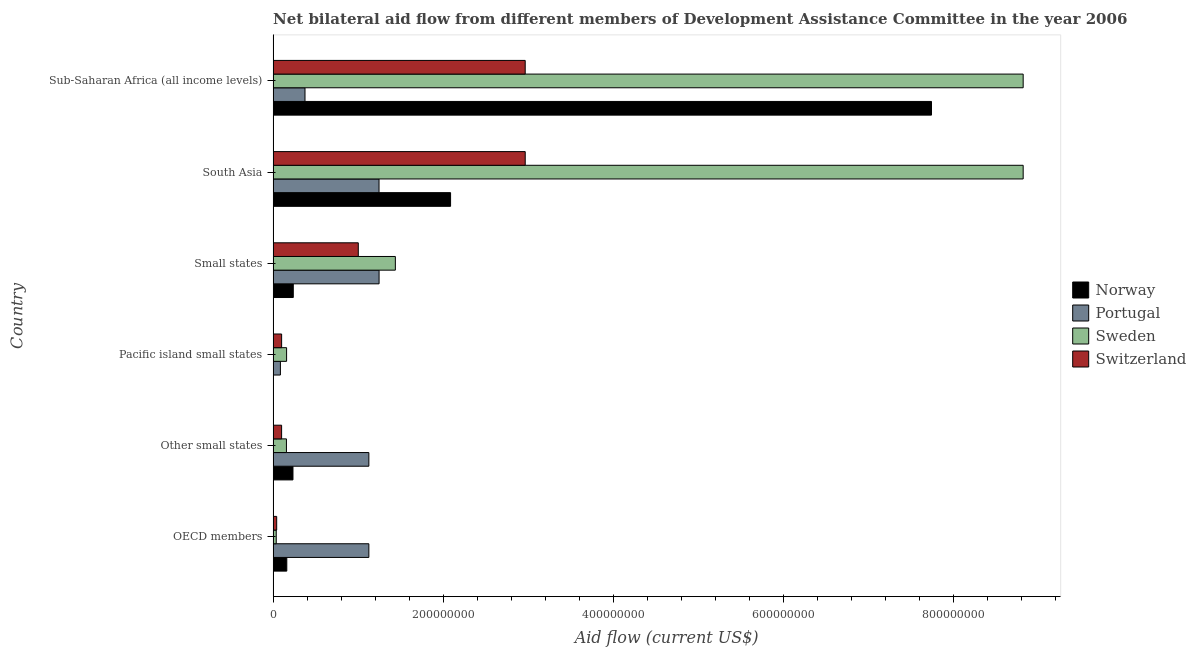How many different coloured bars are there?
Your answer should be very brief. 4. Are the number of bars per tick equal to the number of legend labels?
Your response must be concise. Yes. How many bars are there on the 1st tick from the bottom?
Keep it short and to the point. 4. What is the label of the 5th group of bars from the top?
Offer a very short reply. Other small states. What is the amount of aid given by portugal in Pacific island small states?
Your response must be concise. 8.56e+06. Across all countries, what is the maximum amount of aid given by switzerland?
Keep it short and to the point. 2.96e+08. Across all countries, what is the minimum amount of aid given by switzerland?
Make the answer very short. 4.20e+06. In which country was the amount of aid given by sweden maximum?
Provide a short and direct response. South Asia. In which country was the amount of aid given by norway minimum?
Make the answer very short. Pacific island small states. What is the total amount of aid given by norway in the graph?
Offer a very short reply. 1.05e+09. What is the difference between the amount of aid given by portugal in South Asia and that in Sub-Saharan Africa (all income levels)?
Offer a very short reply. 8.70e+07. What is the difference between the amount of aid given by portugal in Pacific island small states and the amount of aid given by norway in Small states?
Your answer should be compact. -1.51e+07. What is the average amount of aid given by portugal per country?
Make the answer very short. 8.67e+07. What is the difference between the amount of aid given by sweden and amount of aid given by norway in Other small states?
Keep it short and to the point. -7.67e+06. What is the ratio of the amount of aid given by portugal in OECD members to that in Pacific island small states?
Provide a succinct answer. 13.14. Is the difference between the amount of aid given by norway in Pacific island small states and South Asia greater than the difference between the amount of aid given by portugal in Pacific island small states and South Asia?
Offer a very short reply. No. What is the difference between the highest and the second highest amount of aid given by sweden?
Offer a terse response. 0. What is the difference between the highest and the lowest amount of aid given by sweden?
Provide a short and direct response. 8.78e+08. Is it the case that in every country, the sum of the amount of aid given by norway and amount of aid given by switzerland is greater than the sum of amount of aid given by portugal and amount of aid given by sweden?
Provide a short and direct response. No. What does the 1st bar from the bottom in Other small states represents?
Keep it short and to the point. Norway. Is it the case that in every country, the sum of the amount of aid given by norway and amount of aid given by portugal is greater than the amount of aid given by sweden?
Provide a short and direct response. No. What is the difference between two consecutive major ticks on the X-axis?
Ensure brevity in your answer.  2.00e+08. How many legend labels are there?
Your answer should be compact. 4. How are the legend labels stacked?
Provide a succinct answer. Vertical. What is the title of the graph?
Offer a very short reply. Net bilateral aid flow from different members of Development Assistance Committee in the year 2006. Does "United States" appear as one of the legend labels in the graph?
Give a very brief answer. No. What is the label or title of the Y-axis?
Your response must be concise. Country. What is the Aid flow (current US$) in Norway in OECD members?
Offer a very short reply. 1.61e+07. What is the Aid flow (current US$) of Portugal in OECD members?
Provide a succinct answer. 1.13e+08. What is the Aid flow (current US$) of Sweden in OECD members?
Keep it short and to the point. 3.67e+06. What is the Aid flow (current US$) of Switzerland in OECD members?
Keep it short and to the point. 4.20e+06. What is the Aid flow (current US$) of Norway in Other small states?
Make the answer very short. 2.33e+07. What is the Aid flow (current US$) of Portugal in Other small states?
Provide a succinct answer. 1.13e+08. What is the Aid flow (current US$) in Sweden in Other small states?
Ensure brevity in your answer.  1.57e+07. What is the Aid flow (current US$) of Switzerland in Other small states?
Give a very brief answer. 9.98e+06. What is the Aid flow (current US$) in Norway in Pacific island small states?
Keep it short and to the point. 2.00e+04. What is the Aid flow (current US$) in Portugal in Pacific island small states?
Give a very brief answer. 8.56e+06. What is the Aid flow (current US$) in Sweden in Pacific island small states?
Offer a very short reply. 1.58e+07. What is the Aid flow (current US$) of Switzerland in Pacific island small states?
Your answer should be very brief. 1.00e+07. What is the Aid flow (current US$) of Norway in Small states?
Your response must be concise. 2.37e+07. What is the Aid flow (current US$) in Portugal in Small states?
Ensure brevity in your answer.  1.25e+08. What is the Aid flow (current US$) in Sweden in Small states?
Your response must be concise. 1.44e+08. What is the Aid flow (current US$) in Switzerland in Small states?
Provide a succinct answer. 1.00e+08. What is the Aid flow (current US$) of Norway in South Asia?
Offer a terse response. 2.09e+08. What is the Aid flow (current US$) of Portugal in South Asia?
Offer a terse response. 1.24e+08. What is the Aid flow (current US$) in Sweden in South Asia?
Provide a succinct answer. 8.82e+08. What is the Aid flow (current US$) of Switzerland in South Asia?
Keep it short and to the point. 2.96e+08. What is the Aid flow (current US$) of Norway in Sub-Saharan Africa (all income levels)?
Offer a terse response. 7.74e+08. What is the Aid flow (current US$) of Portugal in Sub-Saharan Africa (all income levels)?
Make the answer very short. 3.75e+07. What is the Aid flow (current US$) in Sweden in Sub-Saharan Africa (all income levels)?
Provide a short and direct response. 8.82e+08. What is the Aid flow (current US$) in Switzerland in Sub-Saharan Africa (all income levels)?
Keep it short and to the point. 2.96e+08. Across all countries, what is the maximum Aid flow (current US$) in Norway?
Offer a terse response. 7.74e+08. Across all countries, what is the maximum Aid flow (current US$) in Portugal?
Give a very brief answer. 1.25e+08. Across all countries, what is the maximum Aid flow (current US$) in Sweden?
Provide a short and direct response. 8.82e+08. Across all countries, what is the maximum Aid flow (current US$) of Switzerland?
Provide a succinct answer. 2.96e+08. Across all countries, what is the minimum Aid flow (current US$) of Portugal?
Provide a succinct answer. 8.56e+06. Across all countries, what is the minimum Aid flow (current US$) in Sweden?
Make the answer very short. 3.67e+06. Across all countries, what is the minimum Aid flow (current US$) of Switzerland?
Provide a succinct answer. 4.20e+06. What is the total Aid flow (current US$) in Norway in the graph?
Your answer should be very brief. 1.05e+09. What is the total Aid flow (current US$) in Portugal in the graph?
Provide a succinct answer. 5.20e+08. What is the total Aid flow (current US$) in Sweden in the graph?
Your answer should be compact. 1.94e+09. What is the total Aid flow (current US$) in Switzerland in the graph?
Make the answer very short. 7.17e+08. What is the difference between the Aid flow (current US$) of Norway in OECD members and that in Other small states?
Offer a terse response. -7.26e+06. What is the difference between the Aid flow (current US$) in Sweden in OECD members and that in Other small states?
Offer a very short reply. -1.20e+07. What is the difference between the Aid flow (current US$) in Switzerland in OECD members and that in Other small states?
Ensure brevity in your answer.  -5.78e+06. What is the difference between the Aid flow (current US$) of Norway in OECD members and that in Pacific island small states?
Your response must be concise. 1.60e+07. What is the difference between the Aid flow (current US$) of Portugal in OECD members and that in Pacific island small states?
Offer a terse response. 1.04e+08. What is the difference between the Aid flow (current US$) in Sweden in OECD members and that in Pacific island small states?
Your answer should be very brief. -1.22e+07. What is the difference between the Aid flow (current US$) of Switzerland in OECD members and that in Pacific island small states?
Provide a short and direct response. -5.80e+06. What is the difference between the Aid flow (current US$) in Norway in OECD members and that in Small states?
Provide a short and direct response. -7.63e+06. What is the difference between the Aid flow (current US$) in Portugal in OECD members and that in Small states?
Provide a succinct answer. -1.20e+07. What is the difference between the Aid flow (current US$) in Sweden in OECD members and that in Small states?
Make the answer very short. -1.40e+08. What is the difference between the Aid flow (current US$) of Switzerland in OECD members and that in Small states?
Your response must be concise. -9.59e+07. What is the difference between the Aid flow (current US$) in Norway in OECD members and that in South Asia?
Offer a terse response. -1.92e+08. What is the difference between the Aid flow (current US$) of Portugal in OECD members and that in South Asia?
Your answer should be compact. -1.20e+07. What is the difference between the Aid flow (current US$) of Sweden in OECD members and that in South Asia?
Keep it short and to the point. -8.78e+08. What is the difference between the Aid flow (current US$) of Switzerland in OECD members and that in South Asia?
Make the answer very short. -2.92e+08. What is the difference between the Aid flow (current US$) of Norway in OECD members and that in Sub-Saharan Africa (all income levels)?
Your response must be concise. -7.58e+08. What is the difference between the Aid flow (current US$) of Portugal in OECD members and that in Sub-Saharan Africa (all income levels)?
Your response must be concise. 7.50e+07. What is the difference between the Aid flow (current US$) in Sweden in OECD members and that in Sub-Saharan Africa (all income levels)?
Make the answer very short. -8.78e+08. What is the difference between the Aid flow (current US$) of Switzerland in OECD members and that in Sub-Saharan Africa (all income levels)?
Provide a short and direct response. -2.92e+08. What is the difference between the Aid flow (current US$) in Norway in Other small states and that in Pacific island small states?
Offer a terse response. 2.33e+07. What is the difference between the Aid flow (current US$) in Portugal in Other small states and that in Pacific island small states?
Your answer should be very brief. 1.04e+08. What is the difference between the Aid flow (current US$) in Sweden in Other small states and that in Pacific island small states?
Offer a very short reply. -1.70e+05. What is the difference between the Aid flow (current US$) in Norway in Other small states and that in Small states?
Give a very brief answer. -3.70e+05. What is the difference between the Aid flow (current US$) in Portugal in Other small states and that in Small states?
Your response must be concise. -1.20e+07. What is the difference between the Aid flow (current US$) in Sweden in Other small states and that in Small states?
Provide a short and direct response. -1.28e+08. What is the difference between the Aid flow (current US$) of Switzerland in Other small states and that in Small states?
Keep it short and to the point. -9.01e+07. What is the difference between the Aid flow (current US$) in Norway in Other small states and that in South Asia?
Your response must be concise. -1.85e+08. What is the difference between the Aid flow (current US$) of Portugal in Other small states and that in South Asia?
Ensure brevity in your answer.  -1.20e+07. What is the difference between the Aid flow (current US$) in Sweden in Other small states and that in South Asia?
Your answer should be compact. -8.66e+08. What is the difference between the Aid flow (current US$) of Switzerland in Other small states and that in South Asia?
Your answer should be very brief. -2.86e+08. What is the difference between the Aid flow (current US$) in Norway in Other small states and that in Sub-Saharan Africa (all income levels)?
Your response must be concise. -7.50e+08. What is the difference between the Aid flow (current US$) in Portugal in Other small states and that in Sub-Saharan Africa (all income levels)?
Provide a short and direct response. 7.50e+07. What is the difference between the Aid flow (current US$) of Sweden in Other small states and that in Sub-Saharan Africa (all income levels)?
Ensure brevity in your answer.  -8.66e+08. What is the difference between the Aid flow (current US$) of Switzerland in Other small states and that in Sub-Saharan Africa (all income levels)?
Provide a short and direct response. -2.86e+08. What is the difference between the Aid flow (current US$) in Norway in Pacific island small states and that in Small states?
Provide a short and direct response. -2.37e+07. What is the difference between the Aid flow (current US$) in Portugal in Pacific island small states and that in Small states?
Your response must be concise. -1.16e+08. What is the difference between the Aid flow (current US$) of Sweden in Pacific island small states and that in Small states?
Your answer should be very brief. -1.28e+08. What is the difference between the Aid flow (current US$) in Switzerland in Pacific island small states and that in Small states?
Your answer should be compact. -9.01e+07. What is the difference between the Aid flow (current US$) of Norway in Pacific island small states and that in South Asia?
Give a very brief answer. -2.09e+08. What is the difference between the Aid flow (current US$) of Portugal in Pacific island small states and that in South Asia?
Ensure brevity in your answer.  -1.16e+08. What is the difference between the Aid flow (current US$) of Sweden in Pacific island small states and that in South Asia?
Offer a very short reply. -8.66e+08. What is the difference between the Aid flow (current US$) of Switzerland in Pacific island small states and that in South Asia?
Ensure brevity in your answer.  -2.86e+08. What is the difference between the Aid flow (current US$) in Norway in Pacific island small states and that in Sub-Saharan Africa (all income levels)?
Your answer should be compact. -7.74e+08. What is the difference between the Aid flow (current US$) in Portugal in Pacific island small states and that in Sub-Saharan Africa (all income levels)?
Your response must be concise. -2.89e+07. What is the difference between the Aid flow (current US$) in Sweden in Pacific island small states and that in Sub-Saharan Africa (all income levels)?
Your answer should be compact. -8.66e+08. What is the difference between the Aid flow (current US$) of Switzerland in Pacific island small states and that in Sub-Saharan Africa (all income levels)?
Make the answer very short. -2.86e+08. What is the difference between the Aid flow (current US$) of Norway in Small states and that in South Asia?
Your answer should be very brief. -1.85e+08. What is the difference between the Aid flow (current US$) in Sweden in Small states and that in South Asia?
Your answer should be very brief. -7.38e+08. What is the difference between the Aid flow (current US$) in Switzerland in Small states and that in South Asia?
Give a very brief answer. -1.96e+08. What is the difference between the Aid flow (current US$) of Norway in Small states and that in Sub-Saharan Africa (all income levels)?
Offer a terse response. -7.50e+08. What is the difference between the Aid flow (current US$) of Portugal in Small states and that in Sub-Saharan Africa (all income levels)?
Ensure brevity in your answer.  8.71e+07. What is the difference between the Aid flow (current US$) in Sweden in Small states and that in Sub-Saharan Africa (all income levels)?
Your answer should be compact. -7.38e+08. What is the difference between the Aid flow (current US$) in Switzerland in Small states and that in Sub-Saharan Africa (all income levels)?
Keep it short and to the point. -1.96e+08. What is the difference between the Aid flow (current US$) in Norway in South Asia and that in Sub-Saharan Africa (all income levels)?
Your response must be concise. -5.65e+08. What is the difference between the Aid flow (current US$) of Portugal in South Asia and that in Sub-Saharan Africa (all income levels)?
Your response must be concise. 8.70e+07. What is the difference between the Aid flow (current US$) in Norway in OECD members and the Aid flow (current US$) in Portugal in Other small states?
Give a very brief answer. -9.64e+07. What is the difference between the Aid flow (current US$) of Norway in OECD members and the Aid flow (current US$) of Sweden in Other small states?
Offer a very short reply. 4.10e+05. What is the difference between the Aid flow (current US$) of Norway in OECD members and the Aid flow (current US$) of Switzerland in Other small states?
Make the answer very short. 6.09e+06. What is the difference between the Aid flow (current US$) in Portugal in OECD members and the Aid flow (current US$) in Sweden in Other small states?
Provide a succinct answer. 9.69e+07. What is the difference between the Aid flow (current US$) of Portugal in OECD members and the Aid flow (current US$) of Switzerland in Other small states?
Keep it short and to the point. 1.03e+08. What is the difference between the Aid flow (current US$) in Sweden in OECD members and the Aid flow (current US$) in Switzerland in Other small states?
Keep it short and to the point. -6.31e+06. What is the difference between the Aid flow (current US$) in Norway in OECD members and the Aid flow (current US$) in Portugal in Pacific island small states?
Keep it short and to the point. 7.51e+06. What is the difference between the Aid flow (current US$) in Norway in OECD members and the Aid flow (current US$) in Sweden in Pacific island small states?
Provide a short and direct response. 2.40e+05. What is the difference between the Aid flow (current US$) of Norway in OECD members and the Aid flow (current US$) of Switzerland in Pacific island small states?
Provide a short and direct response. 6.07e+06. What is the difference between the Aid flow (current US$) in Portugal in OECD members and the Aid flow (current US$) in Sweden in Pacific island small states?
Give a very brief answer. 9.67e+07. What is the difference between the Aid flow (current US$) of Portugal in OECD members and the Aid flow (current US$) of Switzerland in Pacific island small states?
Provide a short and direct response. 1.03e+08. What is the difference between the Aid flow (current US$) of Sweden in OECD members and the Aid flow (current US$) of Switzerland in Pacific island small states?
Offer a terse response. -6.33e+06. What is the difference between the Aid flow (current US$) of Norway in OECD members and the Aid flow (current US$) of Portugal in Small states?
Make the answer very short. -1.08e+08. What is the difference between the Aid flow (current US$) in Norway in OECD members and the Aid flow (current US$) in Sweden in Small states?
Make the answer very short. -1.28e+08. What is the difference between the Aid flow (current US$) of Norway in OECD members and the Aid flow (current US$) of Switzerland in Small states?
Keep it short and to the point. -8.40e+07. What is the difference between the Aid flow (current US$) in Portugal in OECD members and the Aid flow (current US$) in Sweden in Small states?
Offer a terse response. -3.11e+07. What is the difference between the Aid flow (current US$) in Portugal in OECD members and the Aid flow (current US$) in Switzerland in Small states?
Make the answer very short. 1.24e+07. What is the difference between the Aid flow (current US$) of Sweden in OECD members and the Aid flow (current US$) of Switzerland in Small states?
Give a very brief answer. -9.64e+07. What is the difference between the Aid flow (current US$) in Norway in OECD members and the Aid flow (current US$) in Portugal in South Asia?
Keep it short and to the point. -1.08e+08. What is the difference between the Aid flow (current US$) of Norway in OECD members and the Aid flow (current US$) of Sweden in South Asia?
Give a very brief answer. -8.65e+08. What is the difference between the Aid flow (current US$) of Norway in OECD members and the Aid flow (current US$) of Switzerland in South Asia?
Offer a very short reply. -2.80e+08. What is the difference between the Aid flow (current US$) of Portugal in OECD members and the Aid flow (current US$) of Sweden in South Asia?
Provide a succinct answer. -7.69e+08. What is the difference between the Aid flow (current US$) of Portugal in OECD members and the Aid flow (current US$) of Switzerland in South Asia?
Your answer should be compact. -1.84e+08. What is the difference between the Aid flow (current US$) in Sweden in OECD members and the Aid flow (current US$) in Switzerland in South Asia?
Offer a terse response. -2.93e+08. What is the difference between the Aid flow (current US$) in Norway in OECD members and the Aid flow (current US$) in Portugal in Sub-Saharan Africa (all income levels)?
Your response must be concise. -2.14e+07. What is the difference between the Aid flow (current US$) of Norway in OECD members and the Aid flow (current US$) of Sweden in Sub-Saharan Africa (all income levels)?
Make the answer very short. -8.65e+08. What is the difference between the Aid flow (current US$) in Norway in OECD members and the Aid flow (current US$) in Switzerland in Sub-Saharan Africa (all income levels)?
Your answer should be very brief. -2.80e+08. What is the difference between the Aid flow (current US$) of Portugal in OECD members and the Aid flow (current US$) of Sweden in Sub-Saharan Africa (all income levels)?
Provide a short and direct response. -7.69e+08. What is the difference between the Aid flow (current US$) in Portugal in OECD members and the Aid flow (current US$) in Switzerland in Sub-Saharan Africa (all income levels)?
Give a very brief answer. -1.84e+08. What is the difference between the Aid flow (current US$) of Sweden in OECD members and the Aid flow (current US$) of Switzerland in Sub-Saharan Africa (all income levels)?
Ensure brevity in your answer.  -2.93e+08. What is the difference between the Aid flow (current US$) of Norway in Other small states and the Aid flow (current US$) of Portugal in Pacific island small states?
Your answer should be very brief. 1.48e+07. What is the difference between the Aid flow (current US$) of Norway in Other small states and the Aid flow (current US$) of Sweden in Pacific island small states?
Ensure brevity in your answer.  7.50e+06. What is the difference between the Aid flow (current US$) of Norway in Other small states and the Aid flow (current US$) of Switzerland in Pacific island small states?
Keep it short and to the point. 1.33e+07. What is the difference between the Aid flow (current US$) in Portugal in Other small states and the Aid flow (current US$) in Sweden in Pacific island small states?
Your answer should be very brief. 9.67e+07. What is the difference between the Aid flow (current US$) in Portugal in Other small states and the Aid flow (current US$) in Switzerland in Pacific island small states?
Provide a succinct answer. 1.03e+08. What is the difference between the Aid flow (current US$) in Sweden in Other small states and the Aid flow (current US$) in Switzerland in Pacific island small states?
Provide a succinct answer. 5.66e+06. What is the difference between the Aid flow (current US$) in Norway in Other small states and the Aid flow (current US$) in Portugal in Small states?
Provide a succinct answer. -1.01e+08. What is the difference between the Aid flow (current US$) of Norway in Other small states and the Aid flow (current US$) of Sweden in Small states?
Provide a succinct answer. -1.20e+08. What is the difference between the Aid flow (current US$) of Norway in Other small states and the Aid flow (current US$) of Switzerland in Small states?
Your answer should be very brief. -7.68e+07. What is the difference between the Aid flow (current US$) in Portugal in Other small states and the Aid flow (current US$) in Sweden in Small states?
Offer a very short reply. -3.11e+07. What is the difference between the Aid flow (current US$) of Portugal in Other small states and the Aid flow (current US$) of Switzerland in Small states?
Your response must be concise. 1.24e+07. What is the difference between the Aid flow (current US$) in Sweden in Other small states and the Aid flow (current US$) in Switzerland in Small states?
Offer a very short reply. -8.44e+07. What is the difference between the Aid flow (current US$) of Norway in Other small states and the Aid flow (current US$) of Portugal in South Asia?
Offer a very short reply. -1.01e+08. What is the difference between the Aid flow (current US$) of Norway in Other small states and the Aid flow (current US$) of Sweden in South Asia?
Offer a terse response. -8.58e+08. What is the difference between the Aid flow (current US$) of Norway in Other small states and the Aid flow (current US$) of Switzerland in South Asia?
Give a very brief answer. -2.73e+08. What is the difference between the Aid flow (current US$) in Portugal in Other small states and the Aid flow (current US$) in Sweden in South Asia?
Give a very brief answer. -7.69e+08. What is the difference between the Aid flow (current US$) in Portugal in Other small states and the Aid flow (current US$) in Switzerland in South Asia?
Make the answer very short. -1.84e+08. What is the difference between the Aid flow (current US$) of Sweden in Other small states and the Aid flow (current US$) of Switzerland in South Asia?
Your response must be concise. -2.81e+08. What is the difference between the Aid flow (current US$) of Norway in Other small states and the Aid flow (current US$) of Portugal in Sub-Saharan Africa (all income levels)?
Give a very brief answer. -1.41e+07. What is the difference between the Aid flow (current US$) of Norway in Other small states and the Aid flow (current US$) of Sweden in Sub-Saharan Africa (all income levels)?
Offer a terse response. -8.58e+08. What is the difference between the Aid flow (current US$) of Norway in Other small states and the Aid flow (current US$) of Switzerland in Sub-Saharan Africa (all income levels)?
Your answer should be compact. -2.73e+08. What is the difference between the Aid flow (current US$) in Portugal in Other small states and the Aid flow (current US$) in Sweden in Sub-Saharan Africa (all income levels)?
Offer a very short reply. -7.69e+08. What is the difference between the Aid flow (current US$) in Portugal in Other small states and the Aid flow (current US$) in Switzerland in Sub-Saharan Africa (all income levels)?
Your answer should be compact. -1.84e+08. What is the difference between the Aid flow (current US$) of Sweden in Other small states and the Aid flow (current US$) of Switzerland in Sub-Saharan Africa (all income levels)?
Offer a very short reply. -2.81e+08. What is the difference between the Aid flow (current US$) of Norway in Pacific island small states and the Aid flow (current US$) of Portugal in Small states?
Offer a terse response. -1.25e+08. What is the difference between the Aid flow (current US$) of Norway in Pacific island small states and the Aid flow (current US$) of Sweden in Small states?
Offer a very short reply. -1.44e+08. What is the difference between the Aid flow (current US$) in Norway in Pacific island small states and the Aid flow (current US$) in Switzerland in Small states?
Your answer should be compact. -1.00e+08. What is the difference between the Aid flow (current US$) in Portugal in Pacific island small states and the Aid flow (current US$) in Sweden in Small states?
Make the answer very short. -1.35e+08. What is the difference between the Aid flow (current US$) of Portugal in Pacific island small states and the Aid flow (current US$) of Switzerland in Small states?
Your answer should be compact. -9.15e+07. What is the difference between the Aid flow (current US$) in Sweden in Pacific island small states and the Aid flow (current US$) in Switzerland in Small states?
Provide a succinct answer. -8.43e+07. What is the difference between the Aid flow (current US$) of Norway in Pacific island small states and the Aid flow (current US$) of Portugal in South Asia?
Your response must be concise. -1.24e+08. What is the difference between the Aid flow (current US$) in Norway in Pacific island small states and the Aid flow (current US$) in Sweden in South Asia?
Keep it short and to the point. -8.82e+08. What is the difference between the Aid flow (current US$) in Norway in Pacific island small states and the Aid flow (current US$) in Switzerland in South Asia?
Your response must be concise. -2.96e+08. What is the difference between the Aid flow (current US$) of Portugal in Pacific island small states and the Aid flow (current US$) of Sweden in South Asia?
Offer a terse response. -8.73e+08. What is the difference between the Aid flow (current US$) in Portugal in Pacific island small states and the Aid flow (current US$) in Switzerland in South Asia?
Provide a succinct answer. -2.88e+08. What is the difference between the Aid flow (current US$) in Sweden in Pacific island small states and the Aid flow (current US$) in Switzerland in South Asia?
Your response must be concise. -2.80e+08. What is the difference between the Aid flow (current US$) of Norway in Pacific island small states and the Aid flow (current US$) of Portugal in Sub-Saharan Africa (all income levels)?
Make the answer very short. -3.74e+07. What is the difference between the Aid flow (current US$) of Norway in Pacific island small states and the Aid flow (current US$) of Sweden in Sub-Saharan Africa (all income levels)?
Make the answer very short. -8.82e+08. What is the difference between the Aid flow (current US$) of Norway in Pacific island small states and the Aid flow (current US$) of Switzerland in Sub-Saharan Africa (all income levels)?
Offer a terse response. -2.96e+08. What is the difference between the Aid flow (current US$) of Portugal in Pacific island small states and the Aid flow (current US$) of Sweden in Sub-Saharan Africa (all income levels)?
Make the answer very short. -8.73e+08. What is the difference between the Aid flow (current US$) in Portugal in Pacific island small states and the Aid flow (current US$) in Switzerland in Sub-Saharan Africa (all income levels)?
Ensure brevity in your answer.  -2.88e+08. What is the difference between the Aid flow (current US$) of Sweden in Pacific island small states and the Aid flow (current US$) of Switzerland in Sub-Saharan Africa (all income levels)?
Your answer should be very brief. -2.80e+08. What is the difference between the Aid flow (current US$) in Norway in Small states and the Aid flow (current US$) in Portugal in South Asia?
Provide a succinct answer. -1.01e+08. What is the difference between the Aid flow (current US$) of Norway in Small states and the Aid flow (current US$) of Sweden in South Asia?
Give a very brief answer. -8.58e+08. What is the difference between the Aid flow (current US$) in Norway in Small states and the Aid flow (current US$) in Switzerland in South Asia?
Offer a very short reply. -2.73e+08. What is the difference between the Aid flow (current US$) in Portugal in Small states and the Aid flow (current US$) in Sweden in South Asia?
Ensure brevity in your answer.  -7.57e+08. What is the difference between the Aid flow (current US$) of Portugal in Small states and the Aid flow (current US$) of Switzerland in South Asia?
Offer a terse response. -1.72e+08. What is the difference between the Aid flow (current US$) in Sweden in Small states and the Aid flow (current US$) in Switzerland in South Asia?
Provide a short and direct response. -1.53e+08. What is the difference between the Aid flow (current US$) in Norway in Small states and the Aid flow (current US$) in Portugal in Sub-Saharan Africa (all income levels)?
Make the answer very short. -1.38e+07. What is the difference between the Aid flow (current US$) of Norway in Small states and the Aid flow (current US$) of Sweden in Sub-Saharan Africa (all income levels)?
Offer a terse response. -8.58e+08. What is the difference between the Aid flow (current US$) in Norway in Small states and the Aid flow (current US$) in Switzerland in Sub-Saharan Africa (all income levels)?
Give a very brief answer. -2.73e+08. What is the difference between the Aid flow (current US$) of Portugal in Small states and the Aid flow (current US$) of Sweden in Sub-Saharan Africa (all income levels)?
Give a very brief answer. -7.57e+08. What is the difference between the Aid flow (current US$) in Portugal in Small states and the Aid flow (current US$) in Switzerland in Sub-Saharan Africa (all income levels)?
Provide a short and direct response. -1.72e+08. What is the difference between the Aid flow (current US$) of Sweden in Small states and the Aid flow (current US$) of Switzerland in Sub-Saharan Africa (all income levels)?
Your answer should be very brief. -1.53e+08. What is the difference between the Aid flow (current US$) of Norway in South Asia and the Aid flow (current US$) of Portugal in Sub-Saharan Africa (all income levels)?
Provide a short and direct response. 1.71e+08. What is the difference between the Aid flow (current US$) of Norway in South Asia and the Aid flow (current US$) of Sweden in Sub-Saharan Africa (all income levels)?
Make the answer very short. -6.73e+08. What is the difference between the Aid flow (current US$) in Norway in South Asia and the Aid flow (current US$) in Switzerland in Sub-Saharan Africa (all income levels)?
Offer a very short reply. -8.77e+07. What is the difference between the Aid flow (current US$) in Portugal in South Asia and the Aid flow (current US$) in Sweden in Sub-Saharan Africa (all income levels)?
Offer a very short reply. -7.57e+08. What is the difference between the Aid flow (current US$) of Portugal in South Asia and the Aid flow (current US$) of Switzerland in Sub-Saharan Africa (all income levels)?
Give a very brief answer. -1.72e+08. What is the difference between the Aid flow (current US$) in Sweden in South Asia and the Aid flow (current US$) in Switzerland in Sub-Saharan Africa (all income levels)?
Provide a short and direct response. 5.85e+08. What is the average Aid flow (current US$) of Norway per country?
Keep it short and to the point. 1.74e+08. What is the average Aid flow (current US$) in Portugal per country?
Ensure brevity in your answer.  8.67e+07. What is the average Aid flow (current US$) in Sweden per country?
Your answer should be compact. 3.24e+08. What is the average Aid flow (current US$) in Switzerland per country?
Provide a short and direct response. 1.19e+08. What is the difference between the Aid flow (current US$) in Norway and Aid flow (current US$) in Portugal in OECD members?
Provide a short and direct response. -9.64e+07. What is the difference between the Aid flow (current US$) of Norway and Aid flow (current US$) of Sweden in OECD members?
Make the answer very short. 1.24e+07. What is the difference between the Aid flow (current US$) in Norway and Aid flow (current US$) in Switzerland in OECD members?
Ensure brevity in your answer.  1.19e+07. What is the difference between the Aid flow (current US$) of Portugal and Aid flow (current US$) of Sweden in OECD members?
Ensure brevity in your answer.  1.09e+08. What is the difference between the Aid flow (current US$) in Portugal and Aid flow (current US$) in Switzerland in OECD members?
Your answer should be very brief. 1.08e+08. What is the difference between the Aid flow (current US$) in Sweden and Aid flow (current US$) in Switzerland in OECD members?
Provide a short and direct response. -5.30e+05. What is the difference between the Aid flow (current US$) in Norway and Aid flow (current US$) in Portugal in Other small states?
Make the answer very short. -8.92e+07. What is the difference between the Aid flow (current US$) of Norway and Aid flow (current US$) of Sweden in Other small states?
Your response must be concise. 7.67e+06. What is the difference between the Aid flow (current US$) in Norway and Aid flow (current US$) in Switzerland in Other small states?
Give a very brief answer. 1.34e+07. What is the difference between the Aid flow (current US$) in Portugal and Aid flow (current US$) in Sweden in Other small states?
Your response must be concise. 9.69e+07. What is the difference between the Aid flow (current US$) in Portugal and Aid flow (current US$) in Switzerland in Other small states?
Provide a succinct answer. 1.03e+08. What is the difference between the Aid flow (current US$) in Sweden and Aid flow (current US$) in Switzerland in Other small states?
Provide a succinct answer. 5.68e+06. What is the difference between the Aid flow (current US$) in Norway and Aid flow (current US$) in Portugal in Pacific island small states?
Give a very brief answer. -8.54e+06. What is the difference between the Aid flow (current US$) of Norway and Aid flow (current US$) of Sweden in Pacific island small states?
Your answer should be very brief. -1.58e+07. What is the difference between the Aid flow (current US$) in Norway and Aid flow (current US$) in Switzerland in Pacific island small states?
Your answer should be very brief. -9.98e+06. What is the difference between the Aid flow (current US$) in Portugal and Aid flow (current US$) in Sweden in Pacific island small states?
Ensure brevity in your answer.  -7.27e+06. What is the difference between the Aid flow (current US$) of Portugal and Aid flow (current US$) of Switzerland in Pacific island small states?
Your answer should be very brief. -1.44e+06. What is the difference between the Aid flow (current US$) in Sweden and Aid flow (current US$) in Switzerland in Pacific island small states?
Offer a very short reply. 5.83e+06. What is the difference between the Aid flow (current US$) in Norway and Aid flow (current US$) in Portugal in Small states?
Keep it short and to the point. -1.01e+08. What is the difference between the Aid flow (current US$) in Norway and Aid flow (current US$) in Sweden in Small states?
Keep it short and to the point. -1.20e+08. What is the difference between the Aid flow (current US$) of Norway and Aid flow (current US$) of Switzerland in Small states?
Your answer should be very brief. -7.64e+07. What is the difference between the Aid flow (current US$) of Portugal and Aid flow (current US$) of Sweden in Small states?
Make the answer very short. -1.91e+07. What is the difference between the Aid flow (current US$) in Portugal and Aid flow (current US$) in Switzerland in Small states?
Your response must be concise. 2.44e+07. What is the difference between the Aid flow (current US$) in Sweden and Aid flow (current US$) in Switzerland in Small states?
Keep it short and to the point. 4.36e+07. What is the difference between the Aid flow (current US$) in Norway and Aid flow (current US$) in Portugal in South Asia?
Provide a succinct answer. 8.41e+07. What is the difference between the Aid flow (current US$) in Norway and Aid flow (current US$) in Sweden in South Asia?
Ensure brevity in your answer.  -6.73e+08. What is the difference between the Aid flow (current US$) of Norway and Aid flow (current US$) of Switzerland in South Asia?
Offer a very short reply. -8.77e+07. What is the difference between the Aid flow (current US$) of Portugal and Aid flow (current US$) of Sweden in South Asia?
Provide a succinct answer. -7.57e+08. What is the difference between the Aid flow (current US$) of Portugal and Aid flow (current US$) of Switzerland in South Asia?
Provide a succinct answer. -1.72e+08. What is the difference between the Aid flow (current US$) in Sweden and Aid flow (current US$) in Switzerland in South Asia?
Your answer should be compact. 5.85e+08. What is the difference between the Aid flow (current US$) of Norway and Aid flow (current US$) of Portugal in Sub-Saharan Africa (all income levels)?
Offer a terse response. 7.36e+08. What is the difference between the Aid flow (current US$) of Norway and Aid flow (current US$) of Sweden in Sub-Saharan Africa (all income levels)?
Provide a short and direct response. -1.08e+08. What is the difference between the Aid flow (current US$) in Norway and Aid flow (current US$) in Switzerland in Sub-Saharan Africa (all income levels)?
Your answer should be very brief. 4.78e+08. What is the difference between the Aid flow (current US$) in Portugal and Aid flow (current US$) in Sweden in Sub-Saharan Africa (all income levels)?
Make the answer very short. -8.44e+08. What is the difference between the Aid flow (current US$) of Portugal and Aid flow (current US$) of Switzerland in Sub-Saharan Africa (all income levels)?
Your answer should be compact. -2.59e+08. What is the difference between the Aid flow (current US$) in Sweden and Aid flow (current US$) in Switzerland in Sub-Saharan Africa (all income levels)?
Keep it short and to the point. 5.85e+08. What is the ratio of the Aid flow (current US$) in Norway in OECD members to that in Other small states?
Offer a terse response. 0.69. What is the ratio of the Aid flow (current US$) in Portugal in OECD members to that in Other small states?
Ensure brevity in your answer.  1. What is the ratio of the Aid flow (current US$) in Sweden in OECD members to that in Other small states?
Provide a succinct answer. 0.23. What is the ratio of the Aid flow (current US$) in Switzerland in OECD members to that in Other small states?
Keep it short and to the point. 0.42. What is the ratio of the Aid flow (current US$) of Norway in OECD members to that in Pacific island small states?
Offer a very short reply. 803.5. What is the ratio of the Aid flow (current US$) in Portugal in OECD members to that in Pacific island small states?
Offer a very short reply. 13.14. What is the ratio of the Aid flow (current US$) of Sweden in OECD members to that in Pacific island small states?
Give a very brief answer. 0.23. What is the ratio of the Aid flow (current US$) of Switzerland in OECD members to that in Pacific island small states?
Your answer should be very brief. 0.42. What is the ratio of the Aid flow (current US$) of Norway in OECD members to that in Small states?
Give a very brief answer. 0.68. What is the ratio of the Aid flow (current US$) of Portugal in OECD members to that in Small states?
Keep it short and to the point. 0.9. What is the ratio of the Aid flow (current US$) in Sweden in OECD members to that in Small states?
Provide a short and direct response. 0.03. What is the ratio of the Aid flow (current US$) of Switzerland in OECD members to that in Small states?
Offer a very short reply. 0.04. What is the ratio of the Aid flow (current US$) in Norway in OECD members to that in South Asia?
Offer a terse response. 0.08. What is the ratio of the Aid flow (current US$) of Portugal in OECD members to that in South Asia?
Your response must be concise. 0.9. What is the ratio of the Aid flow (current US$) of Sweden in OECD members to that in South Asia?
Offer a very short reply. 0. What is the ratio of the Aid flow (current US$) in Switzerland in OECD members to that in South Asia?
Give a very brief answer. 0.01. What is the ratio of the Aid flow (current US$) in Norway in OECD members to that in Sub-Saharan Africa (all income levels)?
Provide a succinct answer. 0.02. What is the ratio of the Aid flow (current US$) in Portugal in OECD members to that in Sub-Saharan Africa (all income levels)?
Your response must be concise. 3. What is the ratio of the Aid flow (current US$) in Sweden in OECD members to that in Sub-Saharan Africa (all income levels)?
Keep it short and to the point. 0. What is the ratio of the Aid flow (current US$) of Switzerland in OECD members to that in Sub-Saharan Africa (all income levels)?
Provide a succinct answer. 0.01. What is the ratio of the Aid flow (current US$) in Norway in Other small states to that in Pacific island small states?
Offer a very short reply. 1166.5. What is the ratio of the Aid flow (current US$) in Portugal in Other small states to that in Pacific island small states?
Provide a short and direct response. 13.14. What is the ratio of the Aid flow (current US$) in Sweden in Other small states to that in Pacific island small states?
Provide a short and direct response. 0.99. What is the ratio of the Aid flow (current US$) in Norway in Other small states to that in Small states?
Provide a short and direct response. 0.98. What is the ratio of the Aid flow (current US$) of Portugal in Other small states to that in Small states?
Offer a very short reply. 0.9. What is the ratio of the Aid flow (current US$) in Sweden in Other small states to that in Small states?
Give a very brief answer. 0.11. What is the ratio of the Aid flow (current US$) of Switzerland in Other small states to that in Small states?
Keep it short and to the point. 0.1. What is the ratio of the Aid flow (current US$) in Norway in Other small states to that in South Asia?
Make the answer very short. 0.11. What is the ratio of the Aid flow (current US$) in Portugal in Other small states to that in South Asia?
Give a very brief answer. 0.9. What is the ratio of the Aid flow (current US$) of Sweden in Other small states to that in South Asia?
Provide a succinct answer. 0.02. What is the ratio of the Aid flow (current US$) in Switzerland in Other small states to that in South Asia?
Provide a short and direct response. 0.03. What is the ratio of the Aid flow (current US$) in Norway in Other small states to that in Sub-Saharan Africa (all income levels)?
Provide a short and direct response. 0.03. What is the ratio of the Aid flow (current US$) of Portugal in Other small states to that in Sub-Saharan Africa (all income levels)?
Provide a succinct answer. 3. What is the ratio of the Aid flow (current US$) in Sweden in Other small states to that in Sub-Saharan Africa (all income levels)?
Make the answer very short. 0.02. What is the ratio of the Aid flow (current US$) in Switzerland in Other small states to that in Sub-Saharan Africa (all income levels)?
Offer a very short reply. 0.03. What is the ratio of the Aid flow (current US$) in Norway in Pacific island small states to that in Small states?
Ensure brevity in your answer.  0. What is the ratio of the Aid flow (current US$) in Portugal in Pacific island small states to that in Small states?
Keep it short and to the point. 0.07. What is the ratio of the Aid flow (current US$) in Sweden in Pacific island small states to that in Small states?
Offer a terse response. 0.11. What is the ratio of the Aid flow (current US$) in Switzerland in Pacific island small states to that in Small states?
Offer a very short reply. 0.1. What is the ratio of the Aid flow (current US$) of Portugal in Pacific island small states to that in South Asia?
Make the answer very short. 0.07. What is the ratio of the Aid flow (current US$) in Sweden in Pacific island small states to that in South Asia?
Your answer should be very brief. 0.02. What is the ratio of the Aid flow (current US$) in Switzerland in Pacific island small states to that in South Asia?
Give a very brief answer. 0.03. What is the ratio of the Aid flow (current US$) of Portugal in Pacific island small states to that in Sub-Saharan Africa (all income levels)?
Give a very brief answer. 0.23. What is the ratio of the Aid flow (current US$) of Sweden in Pacific island small states to that in Sub-Saharan Africa (all income levels)?
Make the answer very short. 0.02. What is the ratio of the Aid flow (current US$) in Switzerland in Pacific island small states to that in Sub-Saharan Africa (all income levels)?
Ensure brevity in your answer.  0.03. What is the ratio of the Aid flow (current US$) in Norway in Small states to that in South Asia?
Offer a terse response. 0.11. What is the ratio of the Aid flow (current US$) of Sweden in Small states to that in South Asia?
Ensure brevity in your answer.  0.16. What is the ratio of the Aid flow (current US$) of Switzerland in Small states to that in South Asia?
Your answer should be compact. 0.34. What is the ratio of the Aid flow (current US$) in Norway in Small states to that in Sub-Saharan Africa (all income levels)?
Provide a succinct answer. 0.03. What is the ratio of the Aid flow (current US$) in Portugal in Small states to that in Sub-Saharan Africa (all income levels)?
Keep it short and to the point. 3.32. What is the ratio of the Aid flow (current US$) of Sweden in Small states to that in Sub-Saharan Africa (all income levels)?
Make the answer very short. 0.16. What is the ratio of the Aid flow (current US$) in Switzerland in Small states to that in Sub-Saharan Africa (all income levels)?
Offer a very short reply. 0.34. What is the ratio of the Aid flow (current US$) of Norway in South Asia to that in Sub-Saharan Africa (all income levels)?
Your answer should be compact. 0.27. What is the ratio of the Aid flow (current US$) of Portugal in South Asia to that in Sub-Saharan Africa (all income levels)?
Provide a short and direct response. 3.32. What is the ratio of the Aid flow (current US$) in Sweden in South Asia to that in Sub-Saharan Africa (all income levels)?
Give a very brief answer. 1. What is the ratio of the Aid flow (current US$) of Switzerland in South Asia to that in Sub-Saharan Africa (all income levels)?
Give a very brief answer. 1. What is the difference between the highest and the second highest Aid flow (current US$) of Norway?
Keep it short and to the point. 5.65e+08. What is the difference between the highest and the second highest Aid flow (current US$) of Switzerland?
Give a very brief answer. 3.00e+04. What is the difference between the highest and the lowest Aid flow (current US$) of Norway?
Give a very brief answer. 7.74e+08. What is the difference between the highest and the lowest Aid flow (current US$) in Portugal?
Your response must be concise. 1.16e+08. What is the difference between the highest and the lowest Aid flow (current US$) in Sweden?
Your response must be concise. 8.78e+08. What is the difference between the highest and the lowest Aid flow (current US$) of Switzerland?
Offer a terse response. 2.92e+08. 